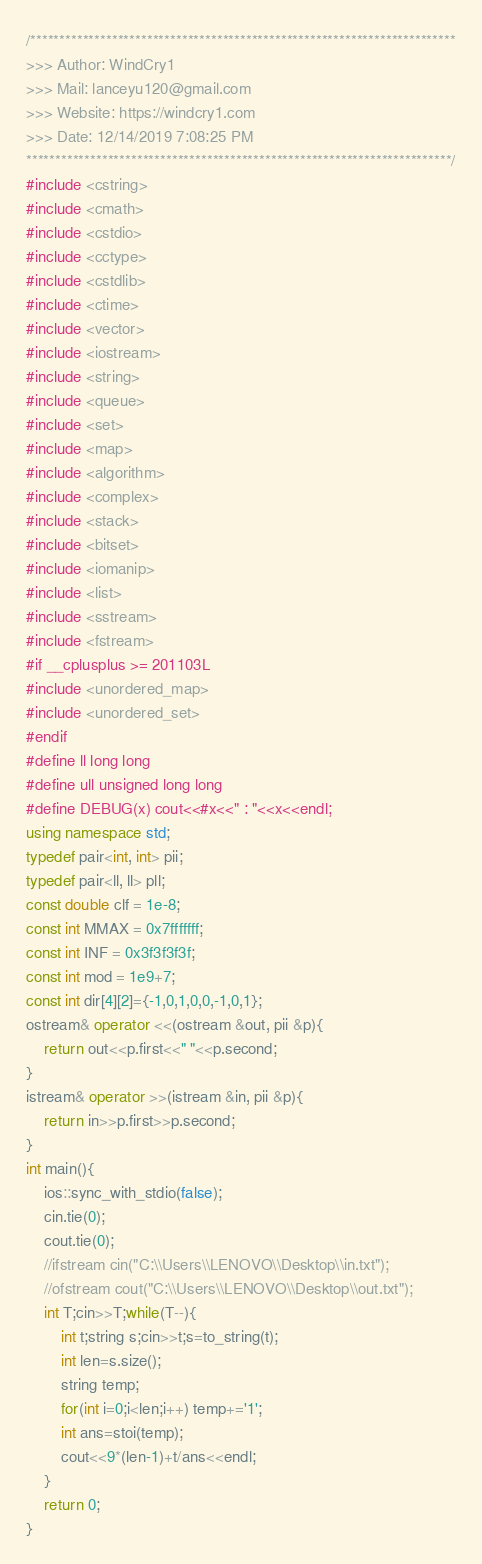Convert code to text. <code><loc_0><loc_0><loc_500><loc_500><_C++_>/*************************************************************************
>>> Author: WindCry1
>>> Mail: lanceyu120@gmail.com
>>> Website: https://windcry1.com
>>> Date: 12/14/2019 7:08:25 PM
*************************************************************************/
#include <cstring>
#include <cmath>
#include <cstdio>
#include <cctype>
#include <cstdlib>
#include <ctime>
#include <vector>
#include <iostream>
#include <string>
#include <queue>
#include <set>
#include <map>
#include <algorithm>
#include <complex>
#include <stack>
#include <bitset>
#include <iomanip>
#include <list>
#include <sstream>
#include <fstream>
#if __cplusplus >= 201103L
#include <unordered_map>
#include <unordered_set>
#endif
#define ll long long
#define ull unsigned long long
#define DEBUG(x) cout<<#x<<" : "<<x<<endl;
using namespace std;
typedef pair<int, int> pii;
typedef pair<ll, ll> pll;
const double clf = 1e-8;
const int MMAX = 0x7fffffff;
const int INF = 0x3f3f3f3f;
const int mod = 1e9+7;
const int dir[4][2]={-1,0,1,0,0,-1,0,1};
ostream& operator <<(ostream &out, pii &p){
	return out<<p.first<<" "<<p.second;
}
istream& operator >>(istream &in, pii &p){
	return in>>p.first>>p.second;
}
int main(){
	ios::sync_with_stdio(false);
	cin.tie(0);
	cout.tie(0);
	//ifstream cin("C:\\Users\\LENOVO\\Desktop\\in.txt");
	//ofstream cout("C:\\Users\\LENOVO\\Desktop\\out.txt");
	int T;cin>>T;while(T--){
		int t;string s;cin>>t;s=to_string(t); 
		int len=s.size();
		string temp;
		for(int i=0;i<len;i++) temp+='1';
		int ans=stoi(temp);
		cout<<9*(len-1)+t/ans<<endl;
	}
	return 0;
}

</code> 